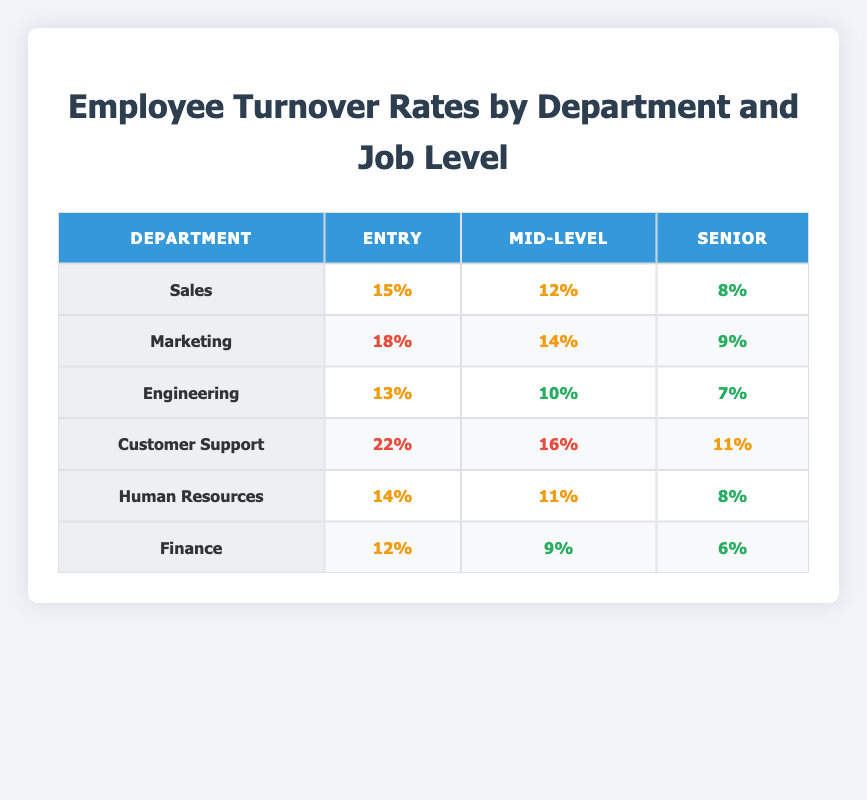What is the turnover rate for Marketing entry-level employees? In the table, under the Marketing row and the Entry column, the turnover rate is listed as 18%.
Answer: 18% Which department has the highest turnover rate for Mid-level employees? Looking at the Mid-level column, Customer Support has the highest turnover rate at 16%, while the next highest is Marketing at 14%.
Answer: Customer Support What is the average turnover rate for Senior employees across all departments? To calculate the average for Senior employees, add up the turnover rates: 8 + 9 + 7 + 11 + 8 + 6 = 49. Then divide by the number of departments (6), which gives 49 / 6 = approximately 8.17%.
Answer: 8.17% Is the turnover rate for Engineering Senior employees lower than that for Sales Senior employees? Engineering has a Senior turnover rate of 7%, while Sales has a Senior turnover rate of 8%. Since 7% is less than 8%, the statement is true.
Answer: Yes What is the difference in turnover rates between Entry and Mid-level employees in the Finance department? The Entry turnover rate for Finance is 12%, and the Mid-level rate is 9%. The difference is 12 - 9 = 3%, meaning Mid-level employees have a lower turnover rate than Entry level.
Answer: 3% Which department experiences the lowest turnover rate for Senior employees? Comparing the Senior turnover rates across all departments, Finance has the lowest rate at 6%.
Answer: Finance How many departments have a turnover rate of 14% or higher for Entry-level employees? Checking the Entry column, Marketing (18%) and Customer Support (22%) exceed 14%. The total number of departments with rates at or above 14% is 2.
Answer: 2 Are there any departments where the turnover rate for Mid-level employees is the same as for Senior employees? Scanning the Mid-level and Senior rows, there are no matching turnover rates for Mid-level and Senior employees in any department. Therefore, the answer is no.
Answer: No What is the turnover rate for the highest-turnover department at any job level? The highest turnover rate noted in the table is for Customer Support under Entry with a turnover rate of 22%.
Answer: 22% 